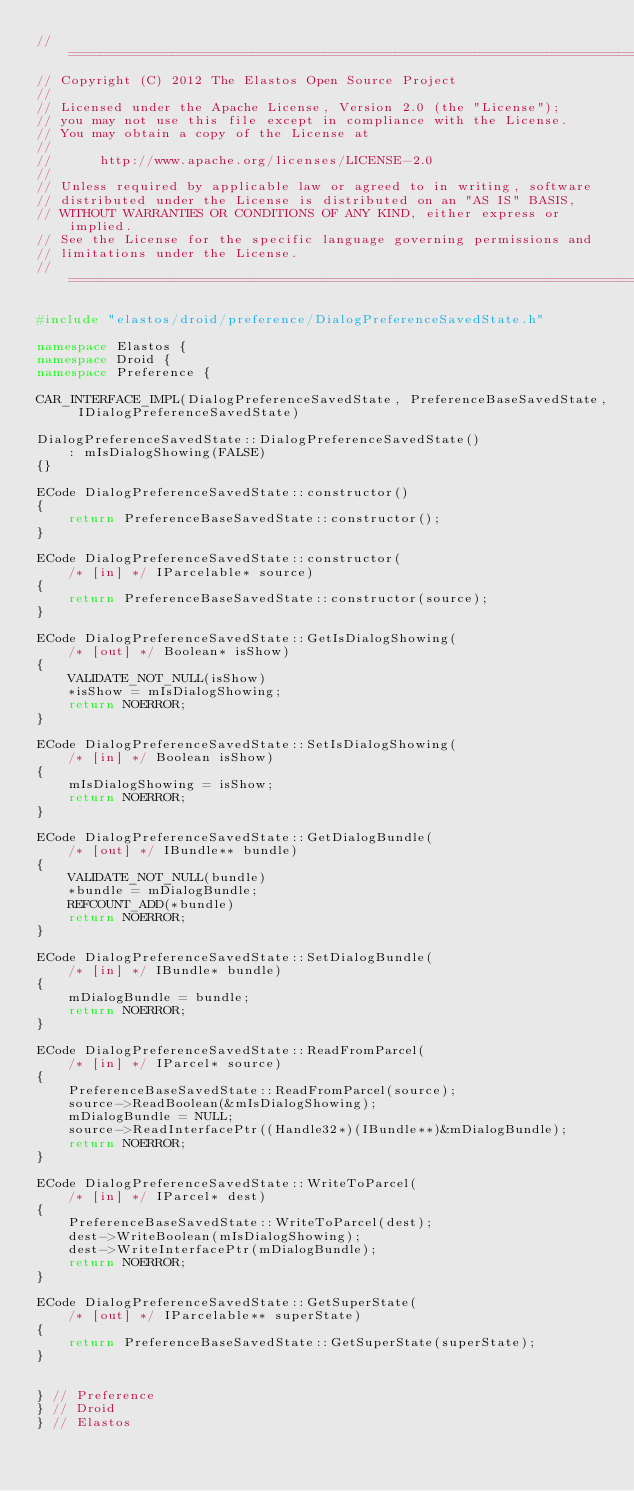<code> <loc_0><loc_0><loc_500><loc_500><_C++_>//=========================================================================
// Copyright (C) 2012 The Elastos Open Source Project
//
// Licensed under the Apache License, Version 2.0 (the "License");
// you may not use this file except in compliance with the License.
// You may obtain a copy of the License at
//
//      http://www.apache.org/licenses/LICENSE-2.0
//
// Unless required by applicable law or agreed to in writing, software
// distributed under the License is distributed on an "AS IS" BASIS,
// WITHOUT WARRANTIES OR CONDITIONS OF ANY KIND, either express or implied.
// See the License for the specific language governing permissions and
// limitations under the License.
//=========================================================================

#include "elastos/droid/preference/DialogPreferenceSavedState.h"

namespace Elastos {
namespace Droid {
namespace Preference {

CAR_INTERFACE_IMPL(DialogPreferenceSavedState, PreferenceBaseSavedState, IDialogPreferenceSavedState)

DialogPreferenceSavedState::DialogPreferenceSavedState()
    : mIsDialogShowing(FALSE)
{}

ECode DialogPreferenceSavedState::constructor()
{
    return PreferenceBaseSavedState::constructor();
}

ECode DialogPreferenceSavedState::constructor(
    /* [in] */ IParcelable* source)
{
    return PreferenceBaseSavedState::constructor(source);
}

ECode DialogPreferenceSavedState::GetIsDialogShowing(
    /* [out] */ Boolean* isShow)
{
    VALIDATE_NOT_NULL(isShow)
    *isShow = mIsDialogShowing;
    return NOERROR;
}

ECode DialogPreferenceSavedState::SetIsDialogShowing(
    /* [in] */ Boolean isShow)
{
    mIsDialogShowing = isShow;
    return NOERROR;
}

ECode DialogPreferenceSavedState::GetDialogBundle(
    /* [out] */ IBundle** bundle)
{
    VALIDATE_NOT_NULL(bundle)
    *bundle = mDialogBundle;
    REFCOUNT_ADD(*bundle)
    return NOERROR;
}

ECode DialogPreferenceSavedState::SetDialogBundle(
    /* [in] */ IBundle* bundle)
{
    mDialogBundle = bundle;
    return NOERROR;
}

ECode DialogPreferenceSavedState::ReadFromParcel(
    /* [in] */ IParcel* source)
{
    PreferenceBaseSavedState::ReadFromParcel(source);
    source->ReadBoolean(&mIsDialogShowing);
    mDialogBundle = NULL;
    source->ReadInterfacePtr((Handle32*)(IBundle**)&mDialogBundle);
    return NOERROR;
}

ECode DialogPreferenceSavedState::WriteToParcel(
    /* [in] */ IParcel* dest)
{
    PreferenceBaseSavedState::WriteToParcel(dest);
    dest->WriteBoolean(mIsDialogShowing);
    dest->WriteInterfacePtr(mDialogBundle);
    return NOERROR;
}

ECode DialogPreferenceSavedState::GetSuperState(
    /* [out] */ IParcelable** superState)
{
    return PreferenceBaseSavedState::GetSuperState(superState);
}


} // Preference
} // Droid
} // Elastos
</code> 